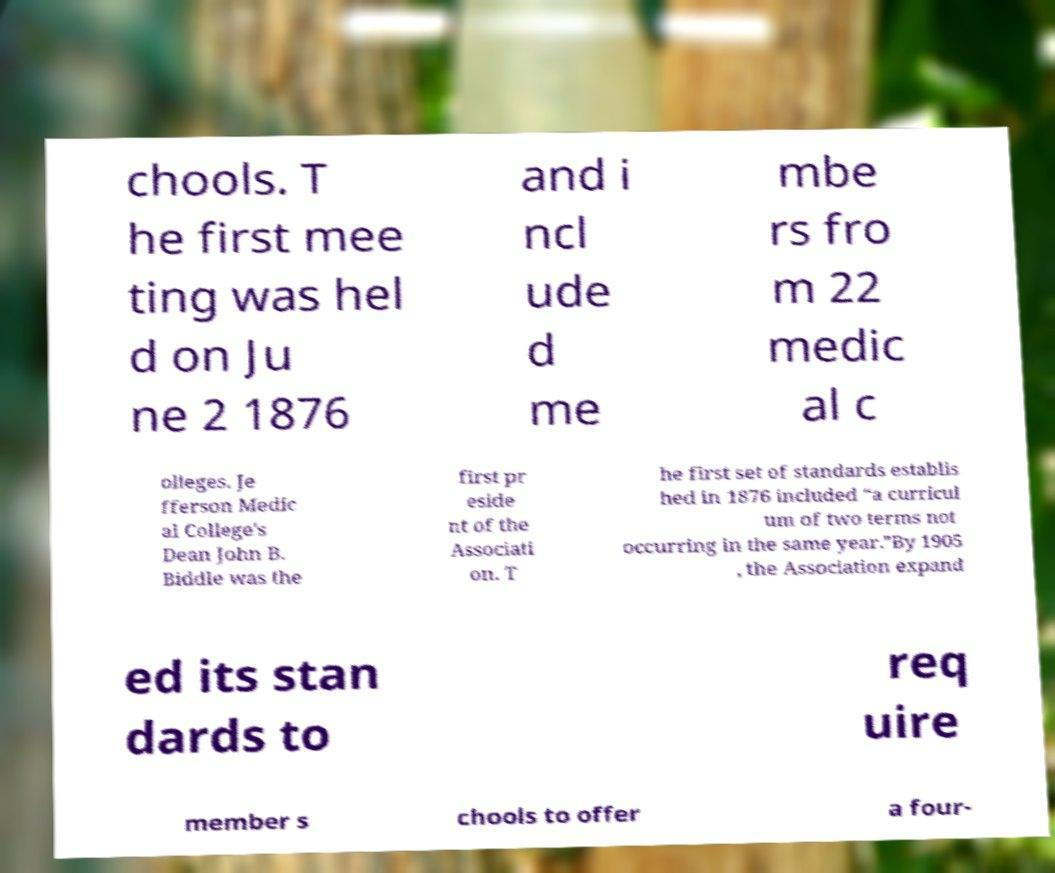Could you assist in decoding the text presented in this image and type it out clearly? chools. T he first mee ting was hel d on Ju ne 2 1876 and i ncl ude d me mbe rs fro m 22 medic al c olleges. Je fferson Medic al College's Dean John B. Biddle was the first pr eside nt of the Associati on. T he first set of standards establis hed in 1876 included “a curricul um of two terms not occurring in the same year.”By 1905 , the Association expand ed its stan dards to req uire member s chools to offer a four- 